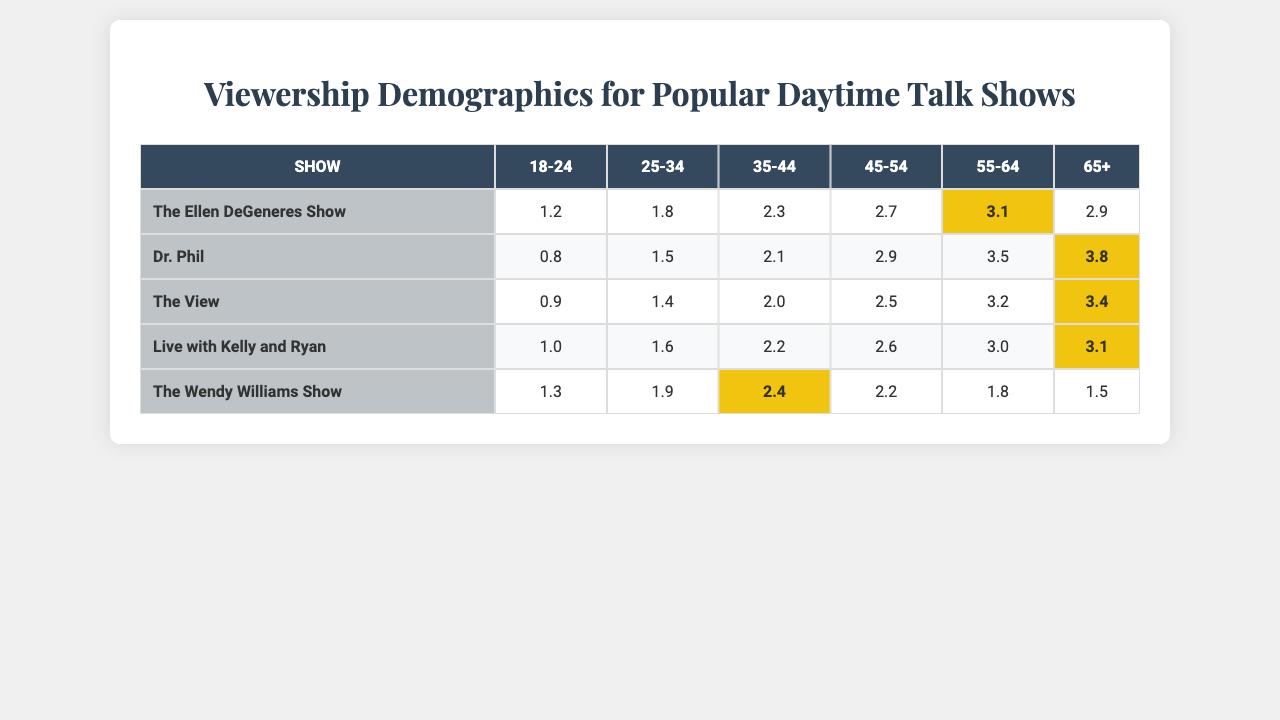What show has the highest viewership among 55-64 age group? Looking at the 55-64 age group column, "Dr. Phil" has the highest viewership number at 3.5.
Answer: Dr. Phil Which age group has the lowest viewership for "The Wendy Williams Show"? For "The Wendy Williams Show," the 65+ age group has the lowest viewership value at 1.5.
Answer: 65+ What is the viewership difference between "The Ellen DeGeneres Show" and "Dr. Phil" in the 35-44 age group? "The Ellen DeGeneres Show" has a viewership of 2.3 and "Dr. Phil" has 2.1 in the 35-44 age group. The difference is 2.3 - 2.1 = 0.2.
Answer: 0.2 Which show has the highest average viewership across all age groups? Calculating the average viewership: "The Ellen DeGeneres Show" = (1.2 + 1.8 + 2.3 + 2.7 + 3.1 + 2.9)/6 = 2.3; "Dr. Phil" = (0.8 + 1.5 + 2.1 + 2.9 + 3.5 + 3.8)/6 = 2.43; "The View" = (0.9 + 1.4 + 2.0 + 2.5 + 3.2 + 3.4)/6 = 2.33; "Live with Kelly and Ryan" = (1.0 + 1.6 + 2.2 + 2.6 + 3.0 + 3.1)/6 = 2.3; "The Wendy Williams Show" = (1.3 + 1.9 + 2.4 + 2.2 + 1.8 + 1.5)/6 = 1.83. The highest average is for "Dr. Phil" with 2.43.
Answer: Dr. Phil Is viewership for "The View" consistently above 2 across all age groups? In the table, the 18-24 and 25-34 age groups for "The View" have viewership numbers of 0.9 and 1.4, respectively, which are not above 2. Thus, they are not consistently above 2.
Answer: No Which age group shows the highest viewership for both "Dr. Phil" and "The Ellen DeGeneres Show"? For "Dr. Phil," the highest is in the 65+ age group at 3.8, and for "The Ellen DeGeneres Show," the highest is in the 55-64 age group at 3.1. Comparing, the highest across both shows is 3.8 in the 65+ age group for "Dr. Phil."
Answer: 65+ for Dr. Phil What is the total viewership for "Live with Kelly and Ryan"? The total viewership can be calculated by adding each age group's viewership: 1.0 + 1.6 + 2.2 + 2.6 + 3.0 + 3.1 = 13.5.
Answer: 13.5 In which age group is "The Wendy Williams Show" the least popular compared to all other shows? In the 55-64 age group, "The Wendy Williams Show" has 1.8, which is lower than "The Ellen DeGeneres Show" (3.1), "Dr. Phil" (3.5), "The View" (3.2), and "Live with Kelly and Ryan" (3.0). Thus, it's the least popular in this age group.
Answer: 55-64 What percentage of the viewership for "The View" comes from the 45-54 age group? For "The View," the viewership in the 45-54 age group is 2.5. The total viewership across all age groups is 0.9 + 1.4 + 2.0 + 2.5 + 3.2 + 3.4 = 13.4. The percentage is (2.5/13.4) * 100 = 18.66%.
Answer: 18.66% Which show has the largest discrepancy in viewership between the youngest and oldest age groups? For "The Ellen DeGeneres Show," the discrepancy is 1.2 (18-24) to 2.9 (65+); for "Dr. Phil," it's from 0.8 to 3.8; for "The View" it's from 0.9 to 3.4; for "Live with Kelly and Ryan," it's from 1.0 to 3.1; and for "The Wendy Williams Show," it's from 1.3 to 1.5. "Dr. Phil" has the largest at 3.0 (3.8 - 0.8).
Answer: Dr. Phil 